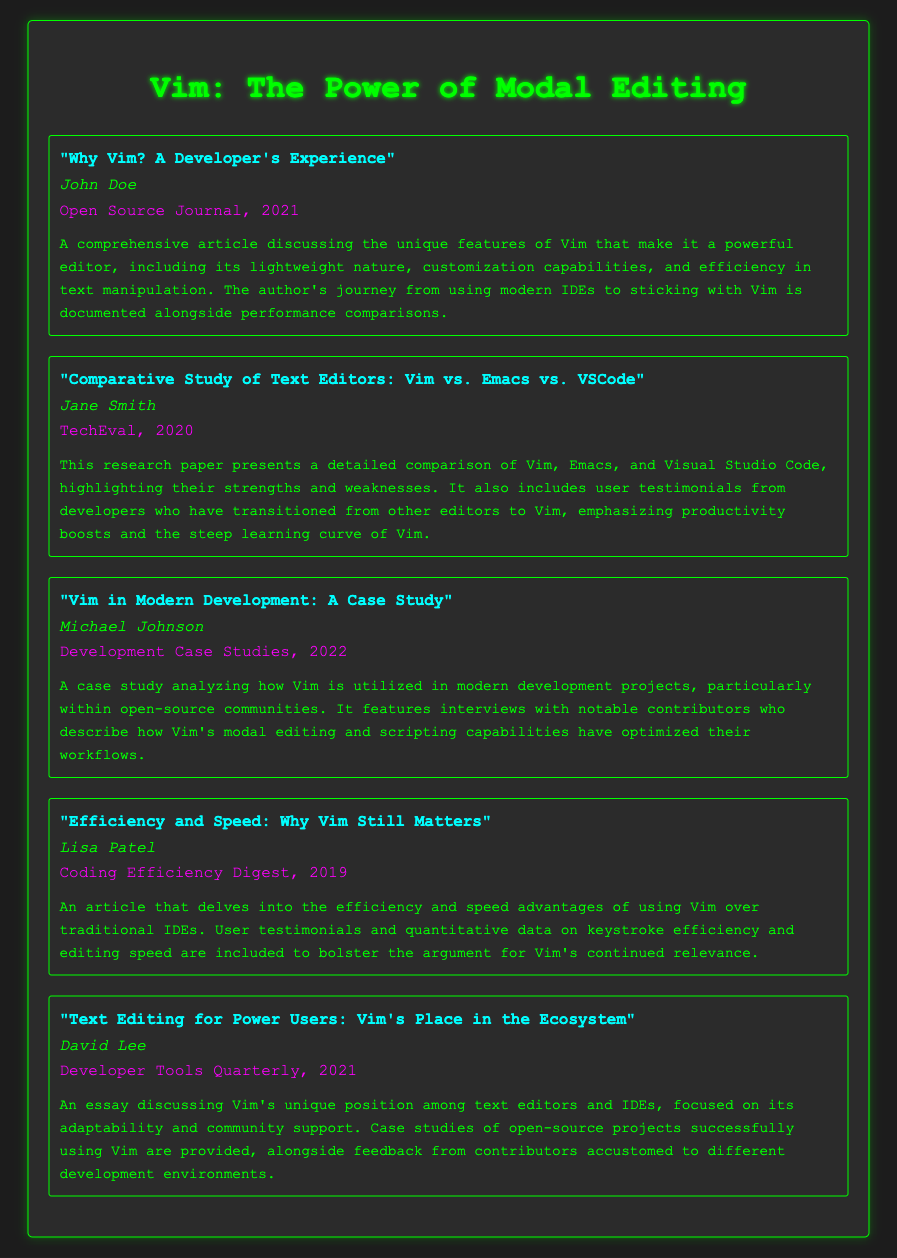What is the title of the first entry? The title of the first entry is mentioned under the "entry-title" class for the corresponding entry.
Answer: "Why Vim? A Developer's Experience" Who authored the article "Efficiency and Speed: Why Vim Still Matters"? The author is listed under the "entry-author" class corresponding to that article.
Answer: Lisa Patel In what year was the article "Comparative Study of Text Editors: Vim vs. Emacs vs. VSCode" published? The publication year is detailed under the "entry-publication" class for that entry.
Answer: 2020 What publication featured the case study titled "Vim in Modern Development"? The publication is specified in the "entry-publication" details of the case study.
Answer: Development Case Studies Which author wrote about user testimonials in the study comparing Vim, Emacs, and VSCode? The author is the individual cited along with the corresponding title discussing user experiences.
Answer: Jane Smith What kind of content is included in the article "Text Editing for Power Users: Vim's Place in the Ecosystem"? This is described in the "entry-details" of the article, indicating what it encompasses.
Answer: Case studies and feedback How many total entries are featured in this bibliography? The count of entries can be tallied from the individual "entry" sections present in the document.
Answer: Five 